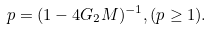<formula> <loc_0><loc_0><loc_500><loc_500>p = ( 1 - 4 G _ { 2 } M ) ^ { - 1 } , ( p \geq 1 ) .</formula> 